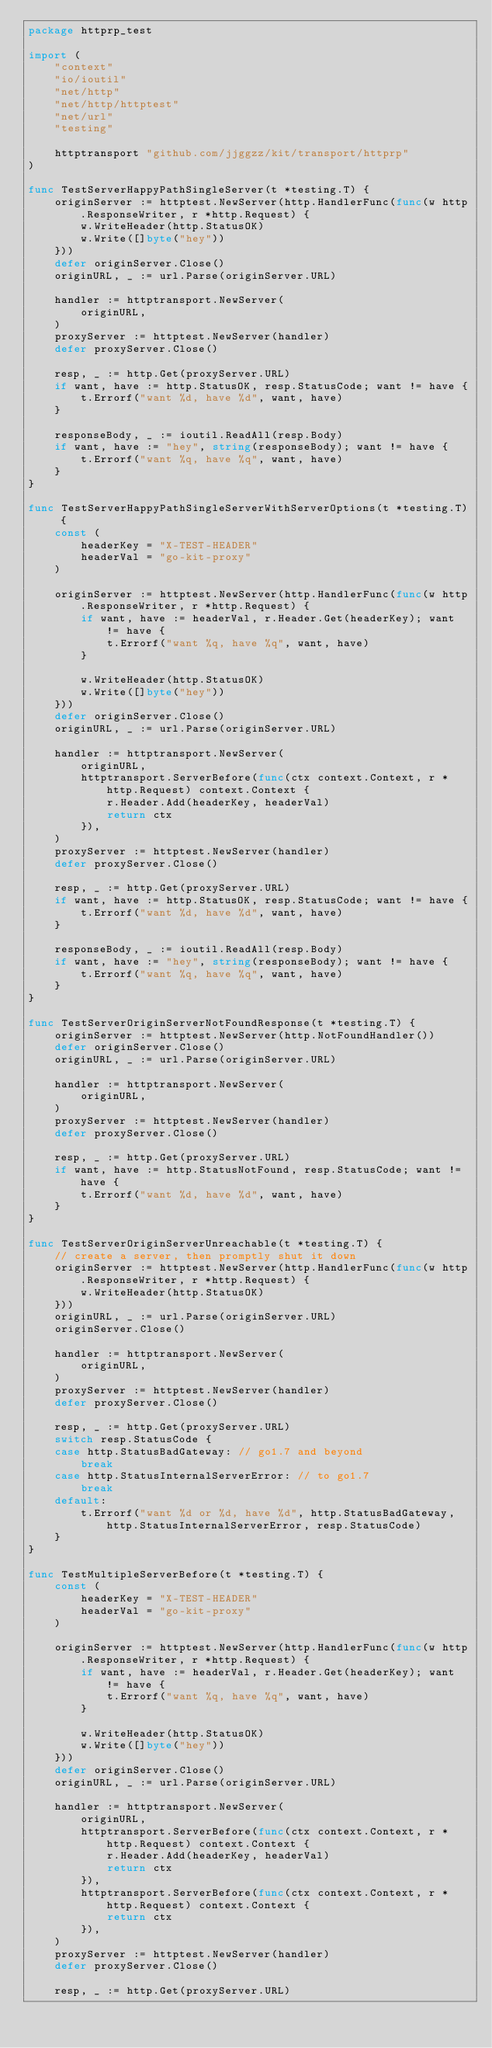Convert code to text. <code><loc_0><loc_0><loc_500><loc_500><_Go_>package httprp_test

import (
	"context"
	"io/ioutil"
	"net/http"
	"net/http/httptest"
	"net/url"
	"testing"

	httptransport "github.com/jjggzz/kit/transport/httprp"
)

func TestServerHappyPathSingleServer(t *testing.T) {
	originServer := httptest.NewServer(http.HandlerFunc(func(w http.ResponseWriter, r *http.Request) {
		w.WriteHeader(http.StatusOK)
		w.Write([]byte("hey"))
	}))
	defer originServer.Close()
	originURL, _ := url.Parse(originServer.URL)

	handler := httptransport.NewServer(
		originURL,
	)
	proxyServer := httptest.NewServer(handler)
	defer proxyServer.Close()

	resp, _ := http.Get(proxyServer.URL)
	if want, have := http.StatusOK, resp.StatusCode; want != have {
		t.Errorf("want %d, have %d", want, have)
	}

	responseBody, _ := ioutil.ReadAll(resp.Body)
	if want, have := "hey", string(responseBody); want != have {
		t.Errorf("want %q, have %q", want, have)
	}
}

func TestServerHappyPathSingleServerWithServerOptions(t *testing.T) {
	const (
		headerKey = "X-TEST-HEADER"
		headerVal = "go-kit-proxy"
	)

	originServer := httptest.NewServer(http.HandlerFunc(func(w http.ResponseWriter, r *http.Request) {
		if want, have := headerVal, r.Header.Get(headerKey); want != have {
			t.Errorf("want %q, have %q", want, have)
		}

		w.WriteHeader(http.StatusOK)
		w.Write([]byte("hey"))
	}))
	defer originServer.Close()
	originURL, _ := url.Parse(originServer.URL)

	handler := httptransport.NewServer(
		originURL,
		httptransport.ServerBefore(func(ctx context.Context, r *http.Request) context.Context {
			r.Header.Add(headerKey, headerVal)
			return ctx
		}),
	)
	proxyServer := httptest.NewServer(handler)
	defer proxyServer.Close()

	resp, _ := http.Get(proxyServer.URL)
	if want, have := http.StatusOK, resp.StatusCode; want != have {
		t.Errorf("want %d, have %d", want, have)
	}

	responseBody, _ := ioutil.ReadAll(resp.Body)
	if want, have := "hey", string(responseBody); want != have {
		t.Errorf("want %q, have %q", want, have)
	}
}

func TestServerOriginServerNotFoundResponse(t *testing.T) {
	originServer := httptest.NewServer(http.NotFoundHandler())
	defer originServer.Close()
	originURL, _ := url.Parse(originServer.URL)

	handler := httptransport.NewServer(
		originURL,
	)
	proxyServer := httptest.NewServer(handler)
	defer proxyServer.Close()

	resp, _ := http.Get(proxyServer.URL)
	if want, have := http.StatusNotFound, resp.StatusCode; want != have {
		t.Errorf("want %d, have %d", want, have)
	}
}

func TestServerOriginServerUnreachable(t *testing.T) {
	// create a server, then promptly shut it down
	originServer := httptest.NewServer(http.HandlerFunc(func(w http.ResponseWriter, r *http.Request) {
		w.WriteHeader(http.StatusOK)
	}))
	originURL, _ := url.Parse(originServer.URL)
	originServer.Close()

	handler := httptransport.NewServer(
		originURL,
	)
	proxyServer := httptest.NewServer(handler)
	defer proxyServer.Close()

	resp, _ := http.Get(proxyServer.URL)
	switch resp.StatusCode {
	case http.StatusBadGateway: // go1.7 and beyond
		break
	case http.StatusInternalServerError: // to go1.7
		break
	default:
		t.Errorf("want %d or %d, have %d", http.StatusBadGateway, http.StatusInternalServerError, resp.StatusCode)
	}
}

func TestMultipleServerBefore(t *testing.T) {
	const (
		headerKey = "X-TEST-HEADER"
		headerVal = "go-kit-proxy"
	)

	originServer := httptest.NewServer(http.HandlerFunc(func(w http.ResponseWriter, r *http.Request) {
		if want, have := headerVal, r.Header.Get(headerKey); want != have {
			t.Errorf("want %q, have %q", want, have)
		}

		w.WriteHeader(http.StatusOK)
		w.Write([]byte("hey"))
	}))
	defer originServer.Close()
	originURL, _ := url.Parse(originServer.URL)

	handler := httptransport.NewServer(
		originURL,
		httptransport.ServerBefore(func(ctx context.Context, r *http.Request) context.Context {
			r.Header.Add(headerKey, headerVal)
			return ctx
		}),
		httptransport.ServerBefore(func(ctx context.Context, r *http.Request) context.Context {
			return ctx
		}),
	)
	proxyServer := httptest.NewServer(handler)
	defer proxyServer.Close()

	resp, _ := http.Get(proxyServer.URL)</code> 